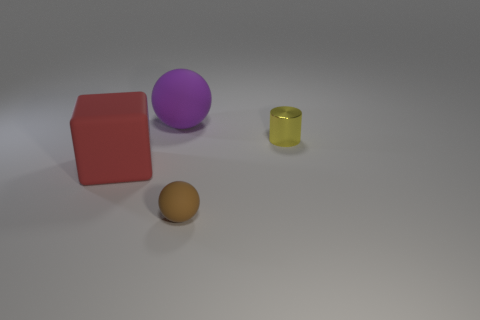Is there any other thing that has the same material as the yellow object?
Give a very brief answer. No. Is the large red thing the same shape as the purple rubber object?
Your answer should be compact. No. What number of matte things are yellow things or small blue cylinders?
Your response must be concise. 0. How many large red rubber objects are there?
Your answer should be compact. 1. What color is the other matte object that is the same size as the purple object?
Your answer should be very brief. Red. Do the brown rubber sphere and the yellow thing have the same size?
Make the answer very short. Yes. There is a yellow thing; is its size the same as the thing that is in front of the matte cube?
Give a very brief answer. Yes. What color is the object that is both behind the large red thing and on the left side of the small metallic cylinder?
Offer a terse response. Purple. Is the number of brown objects behind the large red rubber thing greater than the number of red things that are on the right side of the small rubber thing?
Provide a succinct answer. No. What size is the purple object that is made of the same material as the brown ball?
Keep it short and to the point. Large. 